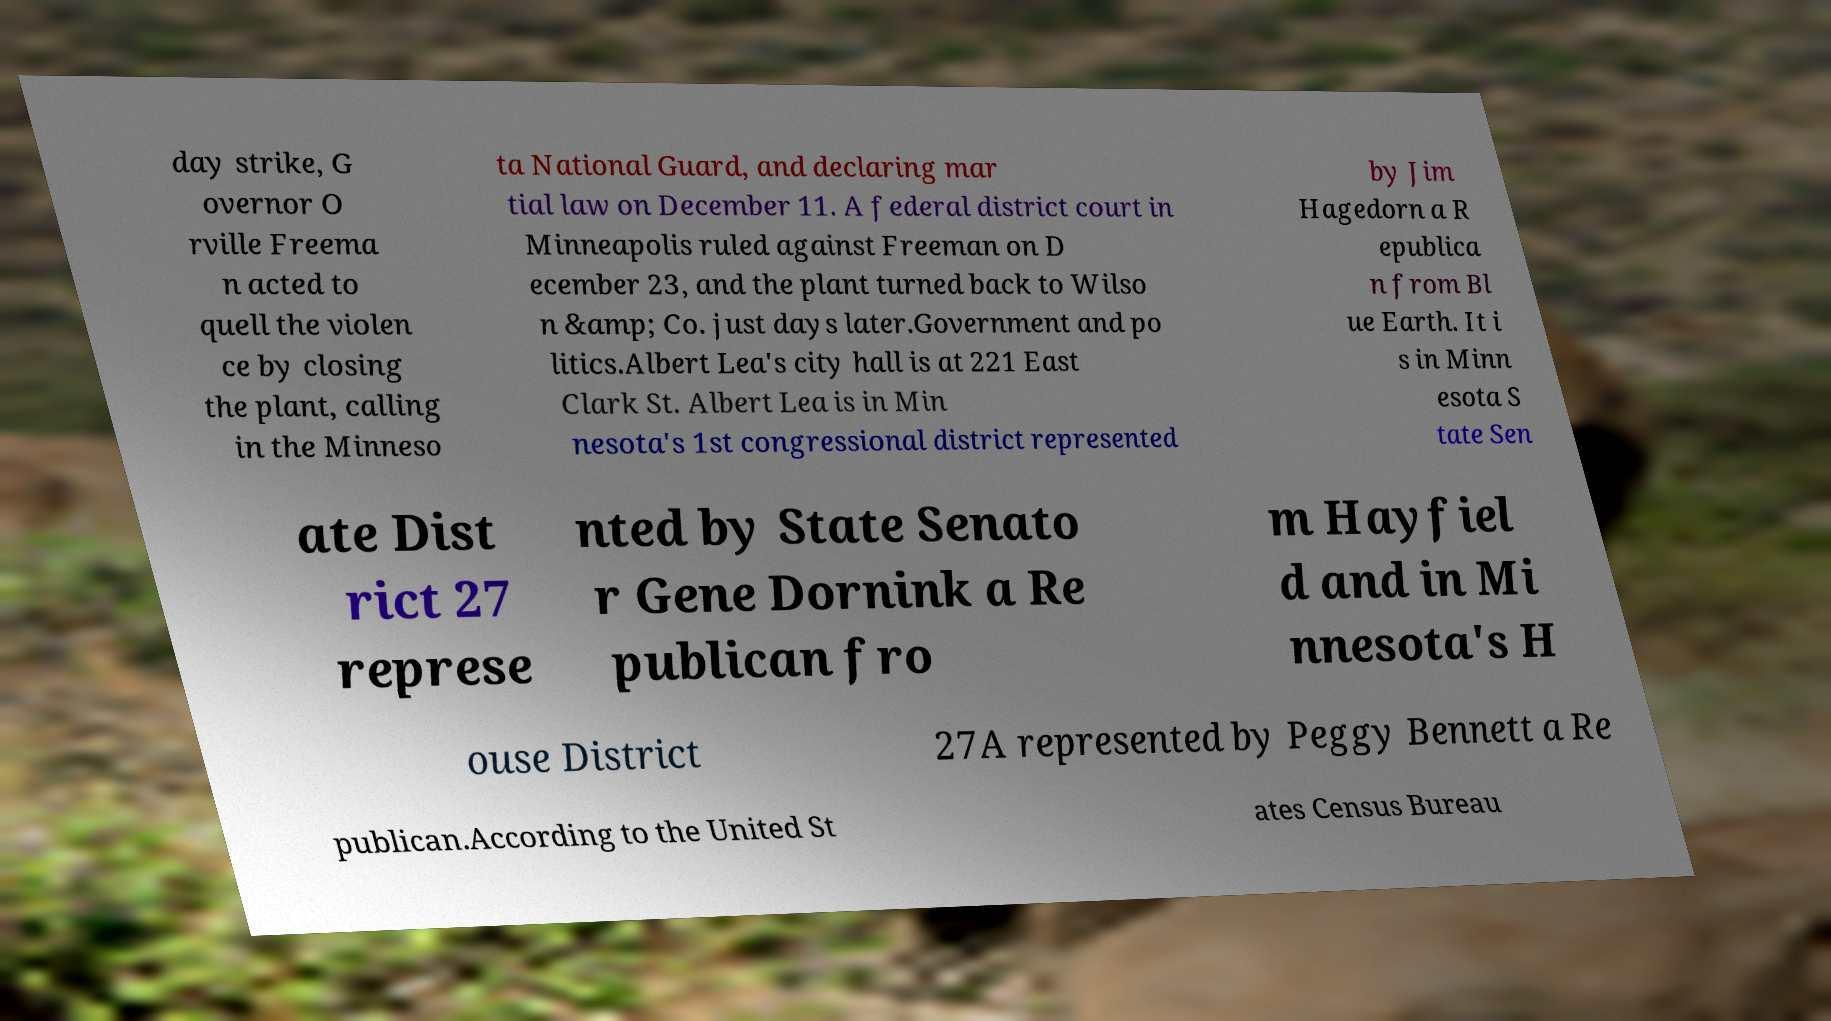There's text embedded in this image that I need extracted. Can you transcribe it verbatim? day strike, G overnor O rville Freema n acted to quell the violen ce by closing the plant, calling in the Minneso ta National Guard, and declaring mar tial law on December 11. A federal district court in Minneapolis ruled against Freeman on D ecember 23, and the plant turned back to Wilso n &amp; Co. just days later.Government and po litics.Albert Lea's city hall is at 221 East Clark St. Albert Lea is in Min nesota's 1st congressional district represented by Jim Hagedorn a R epublica n from Bl ue Earth. It i s in Minn esota S tate Sen ate Dist rict 27 represe nted by State Senato r Gene Dornink a Re publican fro m Hayfiel d and in Mi nnesota's H ouse District 27A represented by Peggy Bennett a Re publican.According to the United St ates Census Bureau 